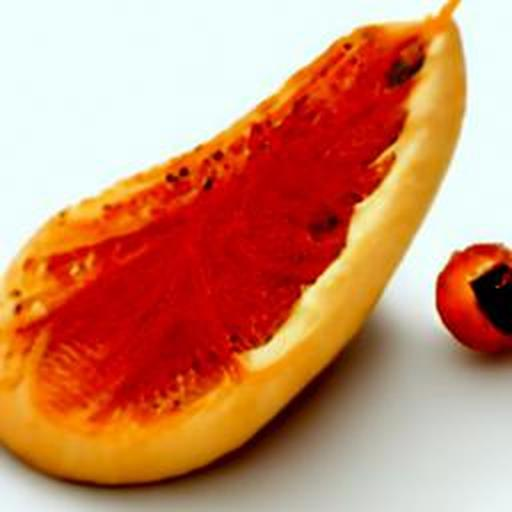How do you determine when a papaya is ripe and ready to eat? A ripe papaya typically has a yellowish or amber-hued skin and yields slightly to gentle pressure. It should feel heavy for its size, indicating juicy ripeness, and exude a sweet, tropical aroma from the base of the stem. 